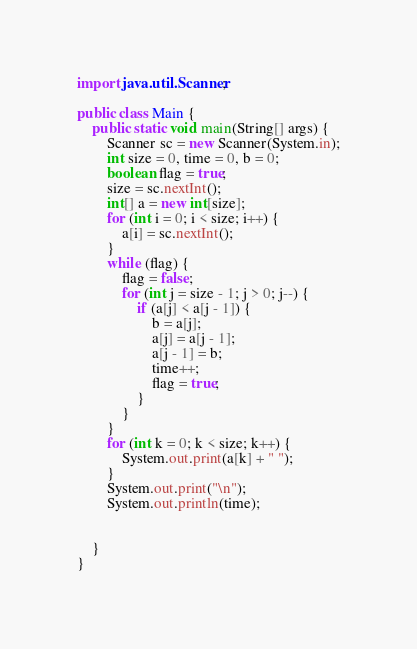<code> <loc_0><loc_0><loc_500><loc_500><_Java_>import java.util.Scanner;

public class Main {
    public static void main(String[] args) {
        Scanner sc = new Scanner(System.in);
        int size = 0, time = 0, b = 0;
        boolean flag = true;
        size = sc.nextInt();
        int[] a = new int[size];
        for (int i = 0; i < size; i++) {
            a[i] = sc.nextInt();
        }
        while (flag) {
            flag = false;
            for (int j = size - 1; j > 0; j--) {
                if (a[j] < a[j - 1]) {
                    b = a[j];
                    a[j] = a[j - 1];
                    a[j - 1] = b;
                    time++;
                    flag = true;
                }
            }
        }
        for (int k = 0; k < size; k++) {
            System.out.print(a[k] + " ");
        }
        System.out.print("\n");
        System.out.println(time);


    }
}

</code> 